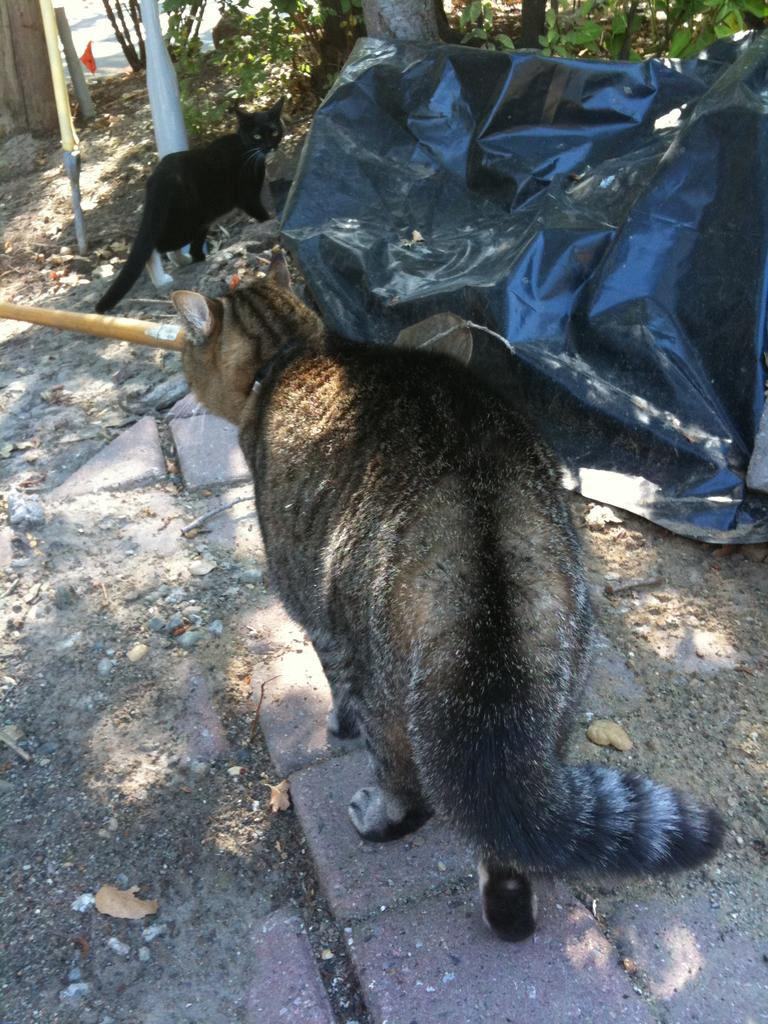What can be seen in the image that people might walk on? There is a path in the image that people might walk on. What animals are present on the path? There are 2 cats on the path. What object is covering something in the image? There is a black cover in the image. What structures are present in the image? There are poles in the image. What type of natural elements can be seen in the image? There are stones and plants in the image. What type of skirt is being blown by the wind in the image? There is no skirt present in the image. What type of tank is visible in the image? There is no tank present in the image. 